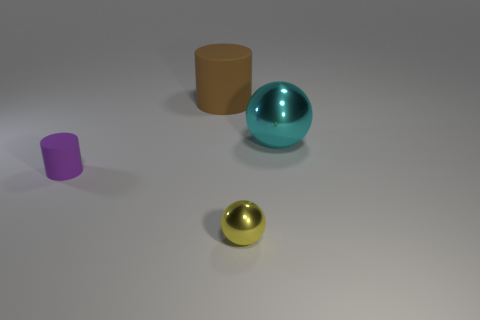Add 4 large green metal blocks. How many objects exist? 8 Add 2 rubber objects. How many rubber objects are left? 4 Add 1 yellow balls. How many yellow balls exist? 2 Subtract 0 gray cylinders. How many objects are left? 4 Subtract all big cyan rubber cylinders. Subtract all tiny rubber cylinders. How many objects are left? 3 